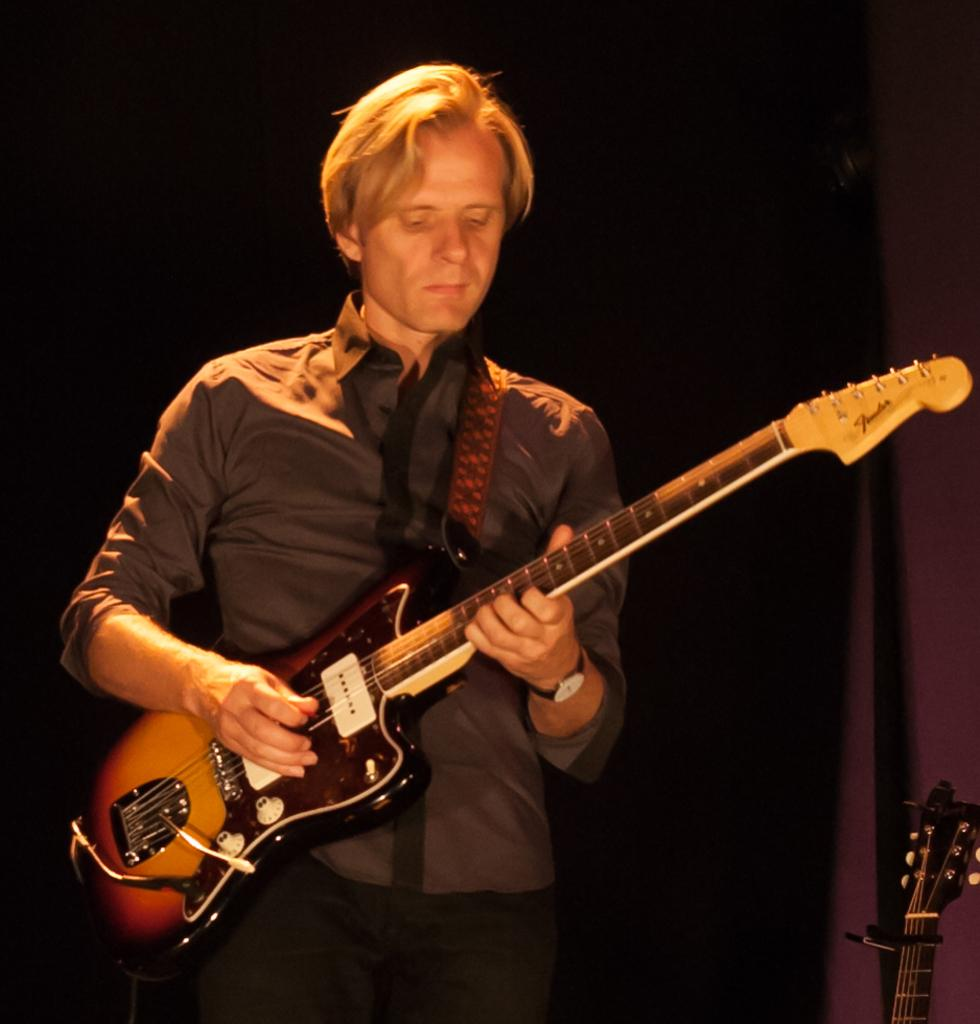What is the main subject of the image? There is a person in the image. What is the person doing in the image? The person is playing a guitar. How many quince are being used by the person in the image? There are no quince present in the image; the person is playing a guitar. What type of clam is visible in the image? There are no clams present in the image; the person is playing a guitar. 